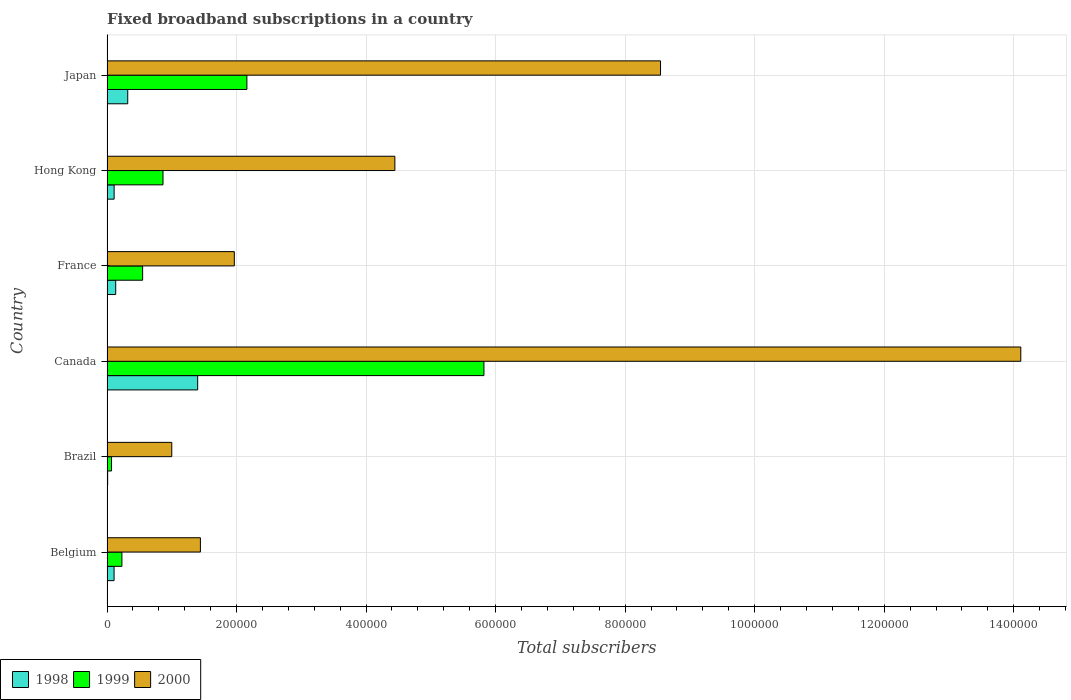Are the number of bars per tick equal to the number of legend labels?
Offer a very short reply. Yes. How many bars are there on the 5th tick from the top?
Keep it short and to the point. 3. What is the number of broadband subscriptions in 2000 in Belgium?
Keep it short and to the point. 1.44e+05. Across all countries, what is the maximum number of broadband subscriptions in 2000?
Make the answer very short. 1.41e+06. In which country was the number of broadband subscriptions in 2000 maximum?
Provide a short and direct response. Canada. What is the total number of broadband subscriptions in 2000 in the graph?
Your response must be concise. 3.15e+06. What is the difference between the number of broadband subscriptions in 1999 in Belgium and that in France?
Ensure brevity in your answer.  -3.20e+04. What is the difference between the number of broadband subscriptions in 1999 in Brazil and the number of broadband subscriptions in 1998 in Belgium?
Ensure brevity in your answer.  -3924. What is the average number of broadband subscriptions in 2000 per country?
Provide a short and direct response. 5.25e+05. What is the difference between the number of broadband subscriptions in 1998 and number of broadband subscriptions in 2000 in France?
Make the answer very short. -1.83e+05. What is the ratio of the number of broadband subscriptions in 2000 in Brazil to that in Japan?
Offer a terse response. 0.12. Is the number of broadband subscriptions in 1999 in Brazil less than that in Hong Kong?
Make the answer very short. Yes. What is the difference between the highest and the second highest number of broadband subscriptions in 1999?
Your response must be concise. 3.66e+05. What is the difference between the highest and the lowest number of broadband subscriptions in 1998?
Your response must be concise. 1.39e+05. In how many countries, is the number of broadband subscriptions in 2000 greater than the average number of broadband subscriptions in 2000 taken over all countries?
Give a very brief answer. 2. What does the 2nd bar from the top in France represents?
Your response must be concise. 1999. What does the 3rd bar from the bottom in Canada represents?
Make the answer very short. 2000. Is it the case that in every country, the sum of the number of broadband subscriptions in 1999 and number of broadband subscriptions in 1998 is greater than the number of broadband subscriptions in 2000?
Offer a terse response. No. How many bars are there?
Make the answer very short. 18. Are all the bars in the graph horizontal?
Provide a succinct answer. Yes. Are the values on the major ticks of X-axis written in scientific E-notation?
Offer a very short reply. No. Does the graph contain any zero values?
Your answer should be compact. No. Does the graph contain grids?
Your answer should be compact. Yes. How are the legend labels stacked?
Your answer should be compact. Horizontal. What is the title of the graph?
Offer a terse response. Fixed broadband subscriptions in a country. Does "1979" appear as one of the legend labels in the graph?
Offer a very short reply. No. What is the label or title of the X-axis?
Make the answer very short. Total subscribers. What is the Total subscribers in 1998 in Belgium?
Offer a terse response. 1.09e+04. What is the Total subscribers of 1999 in Belgium?
Make the answer very short. 2.30e+04. What is the Total subscribers in 2000 in Belgium?
Your response must be concise. 1.44e+05. What is the Total subscribers of 1999 in Brazil?
Offer a very short reply. 7000. What is the Total subscribers of 1998 in Canada?
Ensure brevity in your answer.  1.40e+05. What is the Total subscribers in 1999 in Canada?
Make the answer very short. 5.82e+05. What is the Total subscribers in 2000 in Canada?
Your answer should be very brief. 1.41e+06. What is the Total subscribers of 1998 in France?
Your answer should be very brief. 1.35e+04. What is the Total subscribers in 1999 in France?
Provide a short and direct response. 5.50e+04. What is the Total subscribers of 2000 in France?
Your answer should be very brief. 1.97e+05. What is the Total subscribers in 1998 in Hong Kong?
Offer a very short reply. 1.10e+04. What is the Total subscribers of 1999 in Hong Kong?
Your response must be concise. 8.65e+04. What is the Total subscribers in 2000 in Hong Kong?
Your response must be concise. 4.44e+05. What is the Total subscribers in 1998 in Japan?
Provide a succinct answer. 3.20e+04. What is the Total subscribers of 1999 in Japan?
Offer a terse response. 2.16e+05. What is the Total subscribers of 2000 in Japan?
Provide a succinct answer. 8.55e+05. Across all countries, what is the maximum Total subscribers of 1998?
Give a very brief answer. 1.40e+05. Across all countries, what is the maximum Total subscribers of 1999?
Ensure brevity in your answer.  5.82e+05. Across all countries, what is the maximum Total subscribers in 2000?
Offer a very short reply. 1.41e+06. Across all countries, what is the minimum Total subscribers in 1998?
Your answer should be compact. 1000. Across all countries, what is the minimum Total subscribers in 1999?
Make the answer very short. 7000. Across all countries, what is the minimum Total subscribers in 2000?
Provide a succinct answer. 1.00e+05. What is the total Total subscribers in 1998 in the graph?
Your answer should be compact. 2.08e+05. What is the total Total subscribers of 1999 in the graph?
Your answer should be very brief. 9.69e+05. What is the total Total subscribers in 2000 in the graph?
Provide a short and direct response. 3.15e+06. What is the difference between the Total subscribers of 1998 in Belgium and that in Brazil?
Offer a terse response. 9924. What is the difference between the Total subscribers of 1999 in Belgium and that in Brazil?
Offer a terse response. 1.60e+04. What is the difference between the Total subscribers in 2000 in Belgium and that in Brazil?
Provide a short and direct response. 4.42e+04. What is the difference between the Total subscribers in 1998 in Belgium and that in Canada?
Your response must be concise. -1.29e+05. What is the difference between the Total subscribers in 1999 in Belgium and that in Canada?
Provide a succinct answer. -5.59e+05. What is the difference between the Total subscribers of 2000 in Belgium and that in Canada?
Provide a succinct answer. -1.27e+06. What is the difference between the Total subscribers of 1998 in Belgium and that in France?
Keep it short and to the point. -2540. What is the difference between the Total subscribers of 1999 in Belgium and that in France?
Your answer should be compact. -3.20e+04. What is the difference between the Total subscribers in 2000 in Belgium and that in France?
Provide a succinct answer. -5.24e+04. What is the difference between the Total subscribers of 1998 in Belgium and that in Hong Kong?
Make the answer very short. -76. What is the difference between the Total subscribers in 1999 in Belgium and that in Hong Kong?
Give a very brief answer. -6.35e+04. What is the difference between the Total subscribers of 2000 in Belgium and that in Hong Kong?
Your answer should be very brief. -3.00e+05. What is the difference between the Total subscribers in 1998 in Belgium and that in Japan?
Provide a short and direct response. -2.11e+04. What is the difference between the Total subscribers in 1999 in Belgium and that in Japan?
Provide a succinct answer. -1.93e+05. What is the difference between the Total subscribers in 2000 in Belgium and that in Japan?
Make the answer very short. -7.10e+05. What is the difference between the Total subscribers in 1998 in Brazil and that in Canada?
Give a very brief answer. -1.39e+05. What is the difference between the Total subscribers in 1999 in Brazil and that in Canada?
Your response must be concise. -5.75e+05. What is the difference between the Total subscribers of 2000 in Brazil and that in Canada?
Keep it short and to the point. -1.31e+06. What is the difference between the Total subscribers of 1998 in Brazil and that in France?
Provide a short and direct response. -1.25e+04. What is the difference between the Total subscribers of 1999 in Brazil and that in France?
Provide a succinct answer. -4.80e+04. What is the difference between the Total subscribers of 2000 in Brazil and that in France?
Provide a short and direct response. -9.66e+04. What is the difference between the Total subscribers in 1999 in Brazil and that in Hong Kong?
Provide a succinct answer. -7.95e+04. What is the difference between the Total subscribers of 2000 in Brazil and that in Hong Kong?
Make the answer very short. -3.44e+05. What is the difference between the Total subscribers of 1998 in Brazil and that in Japan?
Keep it short and to the point. -3.10e+04. What is the difference between the Total subscribers of 1999 in Brazil and that in Japan?
Your answer should be compact. -2.09e+05. What is the difference between the Total subscribers of 2000 in Brazil and that in Japan?
Your answer should be compact. -7.55e+05. What is the difference between the Total subscribers in 1998 in Canada and that in France?
Give a very brief answer. 1.27e+05. What is the difference between the Total subscribers in 1999 in Canada and that in France?
Your answer should be compact. 5.27e+05. What is the difference between the Total subscribers in 2000 in Canada and that in France?
Your answer should be very brief. 1.21e+06. What is the difference between the Total subscribers in 1998 in Canada and that in Hong Kong?
Your answer should be very brief. 1.29e+05. What is the difference between the Total subscribers of 1999 in Canada and that in Hong Kong?
Offer a very short reply. 4.96e+05. What is the difference between the Total subscribers in 2000 in Canada and that in Hong Kong?
Provide a short and direct response. 9.66e+05. What is the difference between the Total subscribers in 1998 in Canada and that in Japan?
Offer a very short reply. 1.08e+05. What is the difference between the Total subscribers in 1999 in Canada and that in Japan?
Ensure brevity in your answer.  3.66e+05. What is the difference between the Total subscribers of 2000 in Canada and that in Japan?
Keep it short and to the point. 5.56e+05. What is the difference between the Total subscribers in 1998 in France and that in Hong Kong?
Offer a terse response. 2464. What is the difference between the Total subscribers in 1999 in France and that in Hong Kong?
Your response must be concise. -3.15e+04. What is the difference between the Total subscribers of 2000 in France and that in Hong Kong?
Give a very brief answer. -2.48e+05. What is the difference between the Total subscribers in 1998 in France and that in Japan?
Your answer should be compact. -1.85e+04. What is the difference between the Total subscribers in 1999 in France and that in Japan?
Your answer should be very brief. -1.61e+05. What is the difference between the Total subscribers of 2000 in France and that in Japan?
Your response must be concise. -6.58e+05. What is the difference between the Total subscribers in 1998 in Hong Kong and that in Japan?
Offer a very short reply. -2.10e+04. What is the difference between the Total subscribers in 1999 in Hong Kong and that in Japan?
Provide a short and direct response. -1.30e+05. What is the difference between the Total subscribers in 2000 in Hong Kong and that in Japan?
Make the answer very short. -4.10e+05. What is the difference between the Total subscribers in 1998 in Belgium and the Total subscribers in 1999 in Brazil?
Ensure brevity in your answer.  3924. What is the difference between the Total subscribers in 1998 in Belgium and the Total subscribers in 2000 in Brazil?
Provide a succinct answer. -8.91e+04. What is the difference between the Total subscribers in 1999 in Belgium and the Total subscribers in 2000 in Brazil?
Your response must be concise. -7.70e+04. What is the difference between the Total subscribers in 1998 in Belgium and the Total subscribers in 1999 in Canada?
Offer a terse response. -5.71e+05. What is the difference between the Total subscribers in 1998 in Belgium and the Total subscribers in 2000 in Canada?
Keep it short and to the point. -1.40e+06. What is the difference between the Total subscribers of 1999 in Belgium and the Total subscribers of 2000 in Canada?
Offer a very short reply. -1.39e+06. What is the difference between the Total subscribers of 1998 in Belgium and the Total subscribers of 1999 in France?
Provide a short and direct response. -4.41e+04. What is the difference between the Total subscribers of 1998 in Belgium and the Total subscribers of 2000 in France?
Your answer should be compact. -1.86e+05. What is the difference between the Total subscribers in 1999 in Belgium and the Total subscribers in 2000 in France?
Offer a very short reply. -1.74e+05. What is the difference between the Total subscribers of 1998 in Belgium and the Total subscribers of 1999 in Hong Kong?
Give a very brief answer. -7.55e+04. What is the difference between the Total subscribers of 1998 in Belgium and the Total subscribers of 2000 in Hong Kong?
Give a very brief answer. -4.34e+05. What is the difference between the Total subscribers in 1999 in Belgium and the Total subscribers in 2000 in Hong Kong?
Ensure brevity in your answer.  -4.21e+05. What is the difference between the Total subscribers of 1998 in Belgium and the Total subscribers of 1999 in Japan?
Your answer should be compact. -2.05e+05. What is the difference between the Total subscribers in 1998 in Belgium and the Total subscribers in 2000 in Japan?
Your answer should be very brief. -8.44e+05. What is the difference between the Total subscribers in 1999 in Belgium and the Total subscribers in 2000 in Japan?
Provide a short and direct response. -8.32e+05. What is the difference between the Total subscribers in 1998 in Brazil and the Total subscribers in 1999 in Canada?
Your response must be concise. -5.81e+05. What is the difference between the Total subscribers of 1998 in Brazil and the Total subscribers of 2000 in Canada?
Your answer should be very brief. -1.41e+06. What is the difference between the Total subscribers in 1999 in Brazil and the Total subscribers in 2000 in Canada?
Keep it short and to the point. -1.40e+06. What is the difference between the Total subscribers of 1998 in Brazil and the Total subscribers of 1999 in France?
Offer a terse response. -5.40e+04. What is the difference between the Total subscribers of 1998 in Brazil and the Total subscribers of 2000 in France?
Make the answer very short. -1.96e+05. What is the difference between the Total subscribers in 1999 in Brazil and the Total subscribers in 2000 in France?
Ensure brevity in your answer.  -1.90e+05. What is the difference between the Total subscribers of 1998 in Brazil and the Total subscribers of 1999 in Hong Kong?
Your answer should be very brief. -8.55e+04. What is the difference between the Total subscribers of 1998 in Brazil and the Total subscribers of 2000 in Hong Kong?
Offer a very short reply. -4.43e+05. What is the difference between the Total subscribers in 1999 in Brazil and the Total subscribers in 2000 in Hong Kong?
Your answer should be compact. -4.37e+05. What is the difference between the Total subscribers in 1998 in Brazil and the Total subscribers in 1999 in Japan?
Keep it short and to the point. -2.15e+05. What is the difference between the Total subscribers of 1998 in Brazil and the Total subscribers of 2000 in Japan?
Your response must be concise. -8.54e+05. What is the difference between the Total subscribers of 1999 in Brazil and the Total subscribers of 2000 in Japan?
Give a very brief answer. -8.48e+05. What is the difference between the Total subscribers in 1998 in Canada and the Total subscribers in 1999 in France?
Keep it short and to the point. 8.50e+04. What is the difference between the Total subscribers of 1998 in Canada and the Total subscribers of 2000 in France?
Provide a short and direct response. -5.66e+04. What is the difference between the Total subscribers of 1999 in Canada and the Total subscribers of 2000 in France?
Make the answer very short. 3.85e+05. What is the difference between the Total subscribers in 1998 in Canada and the Total subscribers in 1999 in Hong Kong?
Your answer should be very brief. 5.35e+04. What is the difference between the Total subscribers in 1998 in Canada and the Total subscribers in 2000 in Hong Kong?
Offer a terse response. -3.04e+05. What is the difference between the Total subscribers in 1999 in Canada and the Total subscribers in 2000 in Hong Kong?
Offer a terse response. 1.38e+05. What is the difference between the Total subscribers in 1998 in Canada and the Total subscribers in 1999 in Japan?
Your response must be concise. -7.60e+04. What is the difference between the Total subscribers in 1998 in Canada and the Total subscribers in 2000 in Japan?
Offer a terse response. -7.15e+05. What is the difference between the Total subscribers of 1999 in Canada and the Total subscribers of 2000 in Japan?
Give a very brief answer. -2.73e+05. What is the difference between the Total subscribers in 1998 in France and the Total subscribers in 1999 in Hong Kong?
Your response must be concise. -7.30e+04. What is the difference between the Total subscribers in 1998 in France and the Total subscribers in 2000 in Hong Kong?
Make the answer very short. -4.31e+05. What is the difference between the Total subscribers of 1999 in France and the Total subscribers of 2000 in Hong Kong?
Make the answer very short. -3.89e+05. What is the difference between the Total subscribers in 1998 in France and the Total subscribers in 1999 in Japan?
Make the answer very short. -2.03e+05. What is the difference between the Total subscribers of 1998 in France and the Total subscribers of 2000 in Japan?
Provide a short and direct response. -8.41e+05. What is the difference between the Total subscribers of 1999 in France and the Total subscribers of 2000 in Japan?
Your answer should be very brief. -8.00e+05. What is the difference between the Total subscribers of 1998 in Hong Kong and the Total subscribers of 1999 in Japan?
Your answer should be very brief. -2.05e+05. What is the difference between the Total subscribers in 1998 in Hong Kong and the Total subscribers in 2000 in Japan?
Provide a short and direct response. -8.44e+05. What is the difference between the Total subscribers of 1999 in Hong Kong and the Total subscribers of 2000 in Japan?
Ensure brevity in your answer.  -7.68e+05. What is the average Total subscribers of 1998 per country?
Keep it short and to the point. 3.47e+04. What is the average Total subscribers in 1999 per country?
Ensure brevity in your answer.  1.62e+05. What is the average Total subscribers of 2000 per country?
Your response must be concise. 5.25e+05. What is the difference between the Total subscribers of 1998 and Total subscribers of 1999 in Belgium?
Keep it short and to the point. -1.21e+04. What is the difference between the Total subscribers of 1998 and Total subscribers of 2000 in Belgium?
Give a very brief answer. -1.33e+05. What is the difference between the Total subscribers of 1999 and Total subscribers of 2000 in Belgium?
Your answer should be compact. -1.21e+05. What is the difference between the Total subscribers in 1998 and Total subscribers in 1999 in Brazil?
Provide a short and direct response. -6000. What is the difference between the Total subscribers in 1998 and Total subscribers in 2000 in Brazil?
Your response must be concise. -9.90e+04. What is the difference between the Total subscribers in 1999 and Total subscribers in 2000 in Brazil?
Provide a short and direct response. -9.30e+04. What is the difference between the Total subscribers of 1998 and Total subscribers of 1999 in Canada?
Your answer should be compact. -4.42e+05. What is the difference between the Total subscribers of 1998 and Total subscribers of 2000 in Canada?
Your response must be concise. -1.27e+06. What is the difference between the Total subscribers of 1999 and Total subscribers of 2000 in Canada?
Your answer should be very brief. -8.29e+05. What is the difference between the Total subscribers of 1998 and Total subscribers of 1999 in France?
Offer a very short reply. -4.15e+04. What is the difference between the Total subscribers of 1998 and Total subscribers of 2000 in France?
Ensure brevity in your answer.  -1.83e+05. What is the difference between the Total subscribers in 1999 and Total subscribers in 2000 in France?
Your response must be concise. -1.42e+05. What is the difference between the Total subscribers of 1998 and Total subscribers of 1999 in Hong Kong?
Provide a succinct answer. -7.55e+04. What is the difference between the Total subscribers in 1998 and Total subscribers in 2000 in Hong Kong?
Provide a short and direct response. -4.33e+05. What is the difference between the Total subscribers of 1999 and Total subscribers of 2000 in Hong Kong?
Give a very brief answer. -3.58e+05. What is the difference between the Total subscribers of 1998 and Total subscribers of 1999 in Japan?
Keep it short and to the point. -1.84e+05. What is the difference between the Total subscribers in 1998 and Total subscribers in 2000 in Japan?
Your response must be concise. -8.23e+05. What is the difference between the Total subscribers of 1999 and Total subscribers of 2000 in Japan?
Keep it short and to the point. -6.39e+05. What is the ratio of the Total subscribers of 1998 in Belgium to that in Brazil?
Your response must be concise. 10.92. What is the ratio of the Total subscribers in 1999 in Belgium to that in Brazil?
Keep it short and to the point. 3.29. What is the ratio of the Total subscribers in 2000 in Belgium to that in Brazil?
Provide a short and direct response. 1.44. What is the ratio of the Total subscribers in 1998 in Belgium to that in Canada?
Provide a succinct answer. 0.08. What is the ratio of the Total subscribers of 1999 in Belgium to that in Canada?
Offer a very short reply. 0.04. What is the ratio of the Total subscribers of 2000 in Belgium to that in Canada?
Provide a short and direct response. 0.1. What is the ratio of the Total subscribers in 1998 in Belgium to that in France?
Provide a succinct answer. 0.81. What is the ratio of the Total subscribers in 1999 in Belgium to that in France?
Your answer should be very brief. 0.42. What is the ratio of the Total subscribers in 2000 in Belgium to that in France?
Provide a succinct answer. 0.73. What is the ratio of the Total subscribers in 1998 in Belgium to that in Hong Kong?
Provide a short and direct response. 0.99. What is the ratio of the Total subscribers in 1999 in Belgium to that in Hong Kong?
Ensure brevity in your answer.  0.27. What is the ratio of the Total subscribers in 2000 in Belgium to that in Hong Kong?
Provide a succinct answer. 0.32. What is the ratio of the Total subscribers of 1998 in Belgium to that in Japan?
Give a very brief answer. 0.34. What is the ratio of the Total subscribers in 1999 in Belgium to that in Japan?
Provide a short and direct response. 0.11. What is the ratio of the Total subscribers in 2000 in Belgium to that in Japan?
Offer a very short reply. 0.17. What is the ratio of the Total subscribers in 1998 in Brazil to that in Canada?
Your response must be concise. 0.01. What is the ratio of the Total subscribers in 1999 in Brazil to that in Canada?
Provide a short and direct response. 0.01. What is the ratio of the Total subscribers in 2000 in Brazil to that in Canada?
Your answer should be very brief. 0.07. What is the ratio of the Total subscribers of 1998 in Brazil to that in France?
Your answer should be very brief. 0.07. What is the ratio of the Total subscribers in 1999 in Brazil to that in France?
Your response must be concise. 0.13. What is the ratio of the Total subscribers of 2000 in Brazil to that in France?
Make the answer very short. 0.51. What is the ratio of the Total subscribers of 1998 in Brazil to that in Hong Kong?
Your answer should be compact. 0.09. What is the ratio of the Total subscribers of 1999 in Brazil to that in Hong Kong?
Your answer should be very brief. 0.08. What is the ratio of the Total subscribers in 2000 in Brazil to that in Hong Kong?
Provide a succinct answer. 0.23. What is the ratio of the Total subscribers in 1998 in Brazil to that in Japan?
Give a very brief answer. 0.03. What is the ratio of the Total subscribers in 1999 in Brazil to that in Japan?
Your response must be concise. 0.03. What is the ratio of the Total subscribers of 2000 in Brazil to that in Japan?
Your answer should be very brief. 0.12. What is the ratio of the Total subscribers in 1998 in Canada to that in France?
Offer a terse response. 10.4. What is the ratio of the Total subscribers in 1999 in Canada to that in France?
Your answer should be compact. 10.58. What is the ratio of the Total subscribers in 2000 in Canada to that in France?
Your answer should be compact. 7.18. What is the ratio of the Total subscribers of 1998 in Canada to that in Hong Kong?
Offer a terse response. 12.73. What is the ratio of the Total subscribers in 1999 in Canada to that in Hong Kong?
Make the answer very short. 6.73. What is the ratio of the Total subscribers in 2000 in Canada to that in Hong Kong?
Your answer should be very brief. 3.17. What is the ratio of the Total subscribers in 1998 in Canada to that in Japan?
Make the answer very short. 4.38. What is the ratio of the Total subscribers of 1999 in Canada to that in Japan?
Offer a very short reply. 2.69. What is the ratio of the Total subscribers of 2000 in Canada to that in Japan?
Your response must be concise. 1.65. What is the ratio of the Total subscribers of 1998 in France to that in Hong Kong?
Your answer should be compact. 1.22. What is the ratio of the Total subscribers of 1999 in France to that in Hong Kong?
Offer a terse response. 0.64. What is the ratio of the Total subscribers in 2000 in France to that in Hong Kong?
Offer a very short reply. 0.44. What is the ratio of the Total subscribers of 1998 in France to that in Japan?
Your answer should be very brief. 0.42. What is the ratio of the Total subscribers in 1999 in France to that in Japan?
Your answer should be very brief. 0.25. What is the ratio of the Total subscribers in 2000 in France to that in Japan?
Give a very brief answer. 0.23. What is the ratio of the Total subscribers of 1998 in Hong Kong to that in Japan?
Your answer should be very brief. 0.34. What is the ratio of the Total subscribers in 1999 in Hong Kong to that in Japan?
Provide a succinct answer. 0.4. What is the ratio of the Total subscribers of 2000 in Hong Kong to that in Japan?
Provide a short and direct response. 0.52. What is the difference between the highest and the second highest Total subscribers in 1998?
Keep it short and to the point. 1.08e+05. What is the difference between the highest and the second highest Total subscribers of 1999?
Provide a short and direct response. 3.66e+05. What is the difference between the highest and the second highest Total subscribers in 2000?
Offer a very short reply. 5.56e+05. What is the difference between the highest and the lowest Total subscribers of 1998?
Your answer should be compact. 1.39e+05. What is the difference between the highest and the lowest Total subscribers of 1999?
Offer a terse response. 5.75e+05. What is the difference between the highest and the lowest Total subscribers of 2000?
Ensure brevity in your answer.  1.31e+06. 